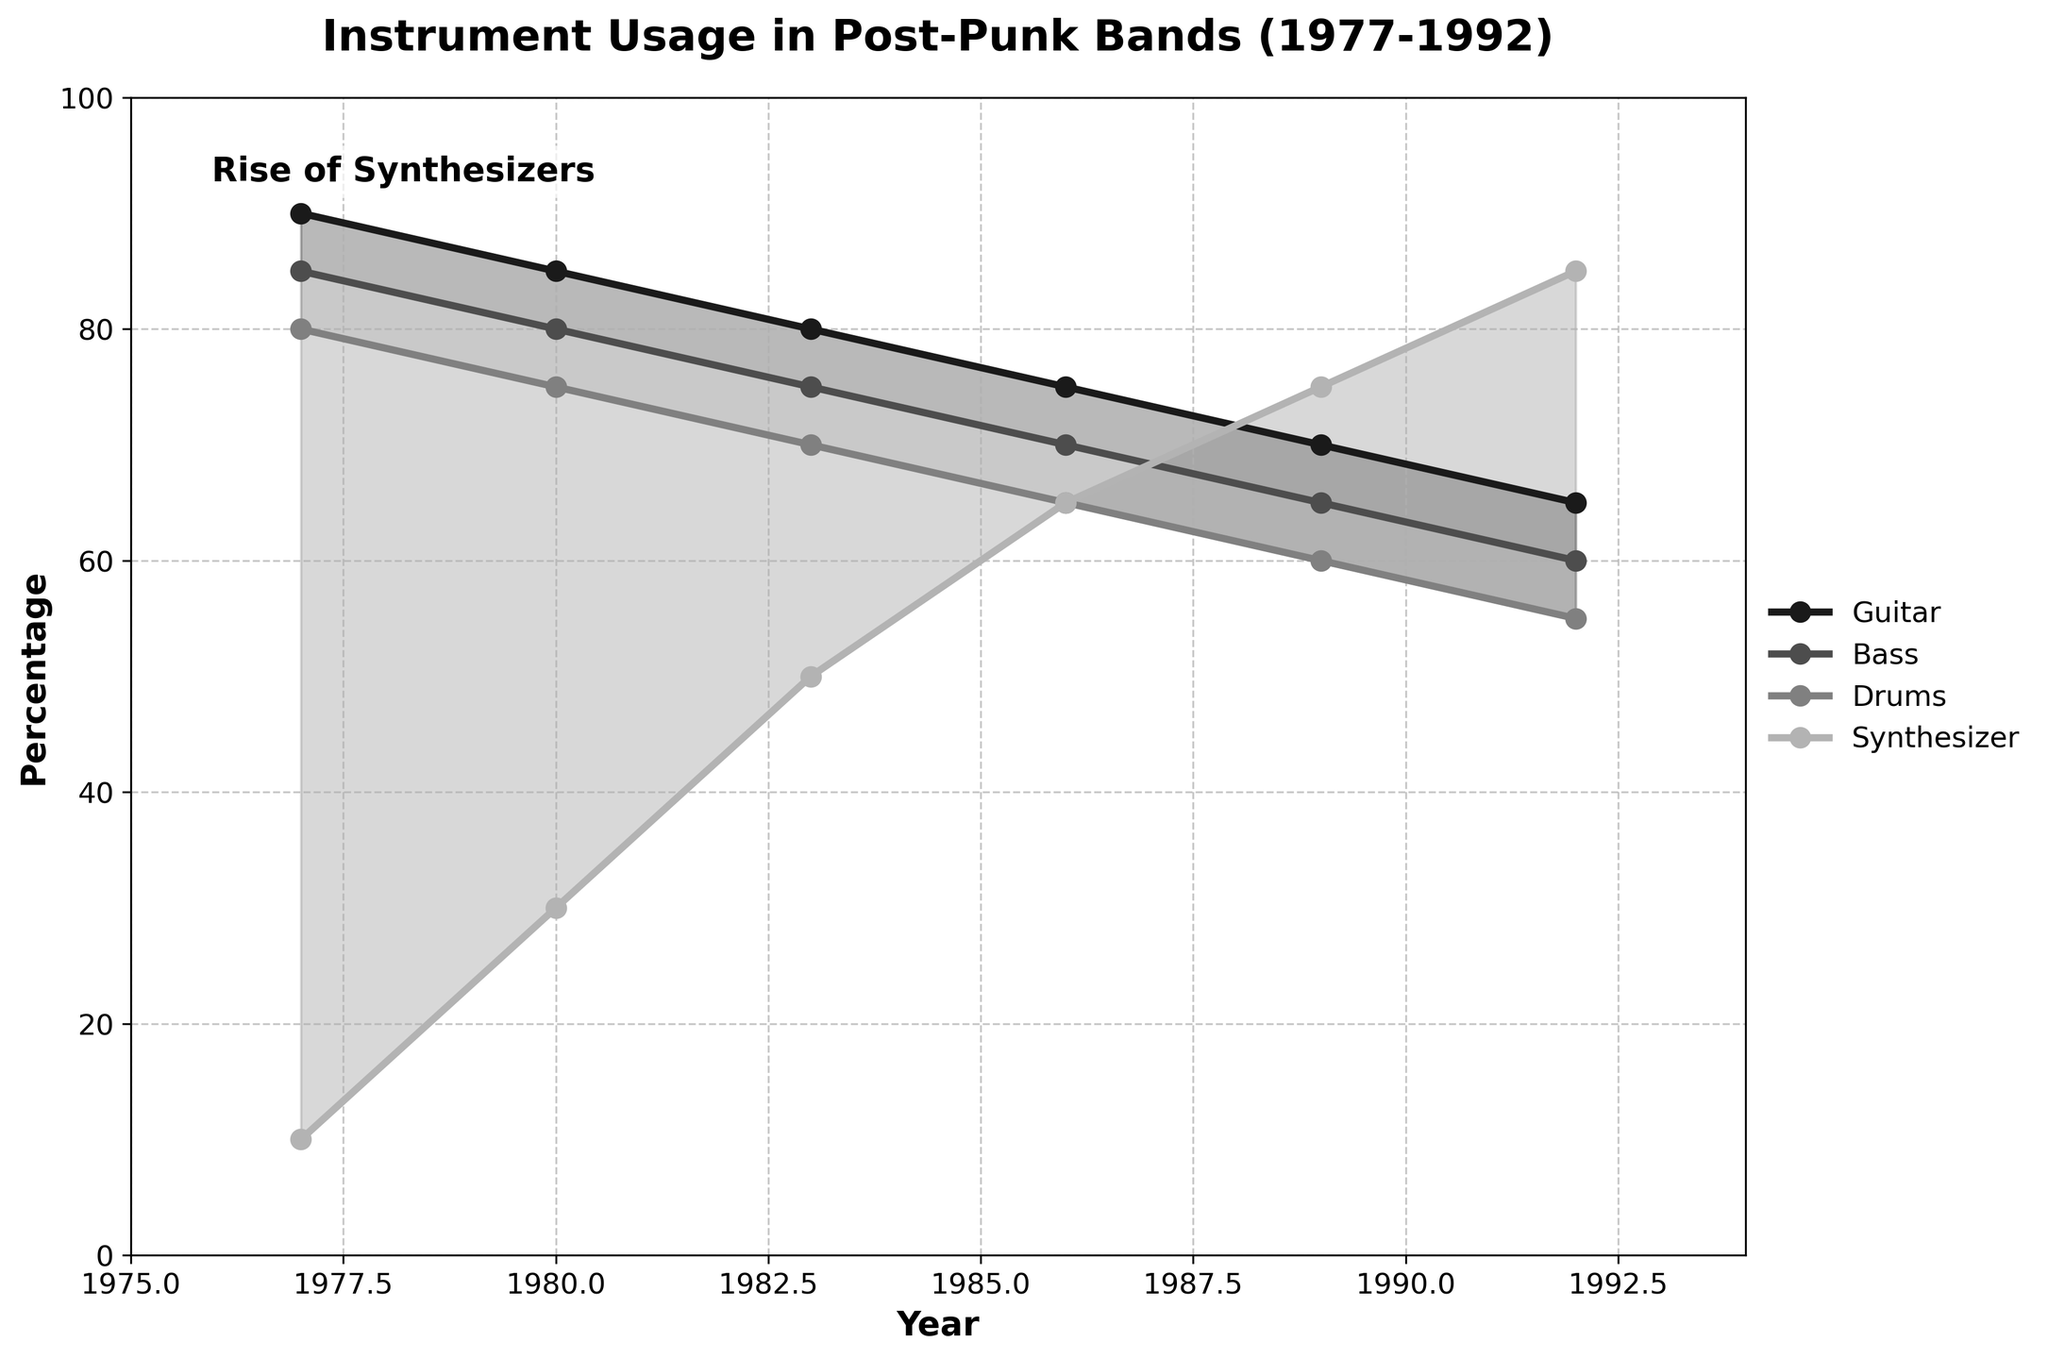What's the title of the plot? The title of the plot is typically displayed at the top of the figure. It summarizes the main point of the plot.
Answer: Instrument Usage in Post-Punk Bands (1977-1992) During which year were guitars used by 75% of bands? Locate the line for guitars and identify where it intersects with the 75% on the y-axis.
Answer: 1986 Which instrument saw the highest increase in usage percentage between 1977 and 1992? Compare the percentages of each instrument in 1977 and 1992. The synthesizer increased from 10% to 85%.
Answer: Synthesizer In what year did the usage of synthesizers surpass the usage of guitars? Identify the points where the synthesizer line is above the guitar line. The synthesizer surpassed the guitar in 1986.
Answer: 1986 By how many percentage points did the usage of bass decline from 1977 to 1992? Subtract the 1992 percentage of bass from the 1977 percentage of bass. 85% - 60%.
Answer: 25 percentage points Which two instruments had the smallest difference in their usage percentages in 1989? Compare the 1989 usage percentages of each pair of instruments. Bass and drums have the smallest difference (5%).
Answer: Bass and Drums What is the trend of synthesizer usage from 1977 to 1992? Observe the synthesizer line from 1977 to 1992; it shows a clear upward trend.
Answer: Increasing During which period was the adoption of synthesizers the most rapid? Compare the slopes of the synthesizer line in the periods 1977-1980, 1980-1983, 1983-1986, 1986-1989, and 1989-1992. The line shows the steepest increase between 1977 and 1980 and between 1983 and 1986.
Answer: 1983-1986 By how many years did the synthesizer usage lead over bass usage when synthesizer usage reached 75%? Synthesizer reached 75% in 1989, while bass started below that percentage; count from the year each reached its respective percentage.
Answer: 3 years Do drums or bass have a higher average usage percentage over the entire period? Calculate the average percentage for both drums and bass over the years provided and compare them. Drums: (80+75+70+65+60+55)/6 = 67.5, Bass: (85+80+75+70+65+60)/6 = 72.5
Answer: Bass 